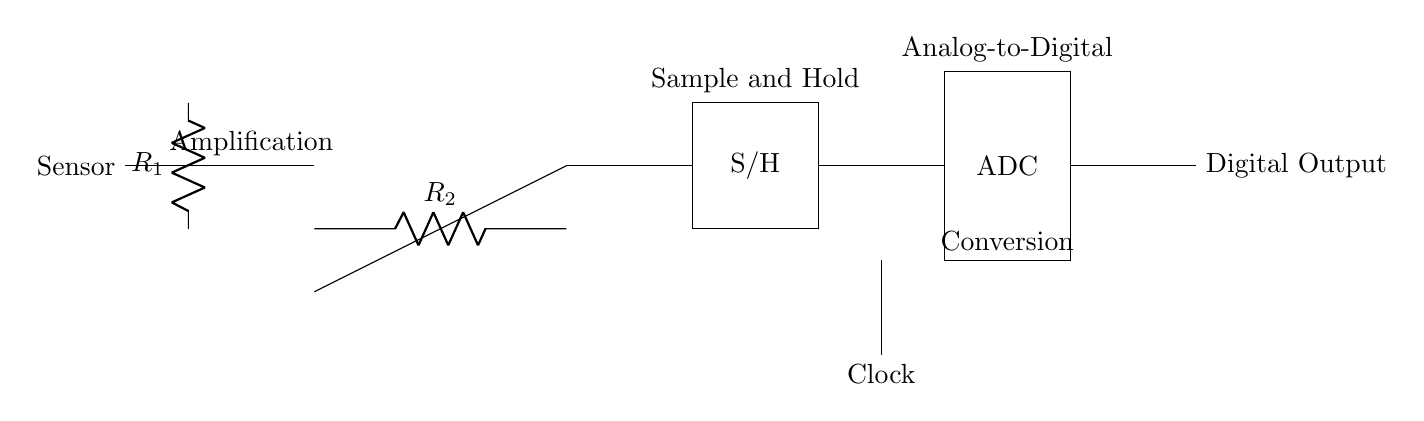What is the main function of the ADC in this circuit? The ADC's main function is to convert an analog signal from the sensor into a digital output that can be processed by digital systems.
Answer: Conversion What type of components are R1 and R2? R1 and R2 are resistors used in the circuit to limit the current and set the gain for the operational amplifier.
Answer: Resistors How many main stages are present in this ADC circuit? There are three main stages: amplification, sample and hold, and analog-to-digital conversion.
Answer: Three What is the role of the Sample and Hold component? The Sample and Hold component captures and holds the voltage from the amplifier for a brief period, allowing the ADC to convert it to a digital value accurately.
Answer: Capture voltage Which component is responsible for timing in the circuit? The Clock component provides the necessary timing signals that coordinate the actions of the ADC during the conversion process.
Answer: Clock What might happen if R1 is too high? If R1 is too high, it could limit the current excessively, potentially leading to insufficient voltage at the input of the operational amplifier and affecting the overall performance of the circuit.
Answer: Insufficient voltage What is the significance of the 'Digital Output' node? The 'Digital Output' node indicates where the processed digital signal from the ADC is made available for further digital processing or interfacing.
Answer: Output point 